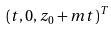Convert formula to latex. <formula><loc_0><loc_0><loc_500><loc_500>( t , 0 , z _ { 0 } + m t ) ^ { T }</formula> 